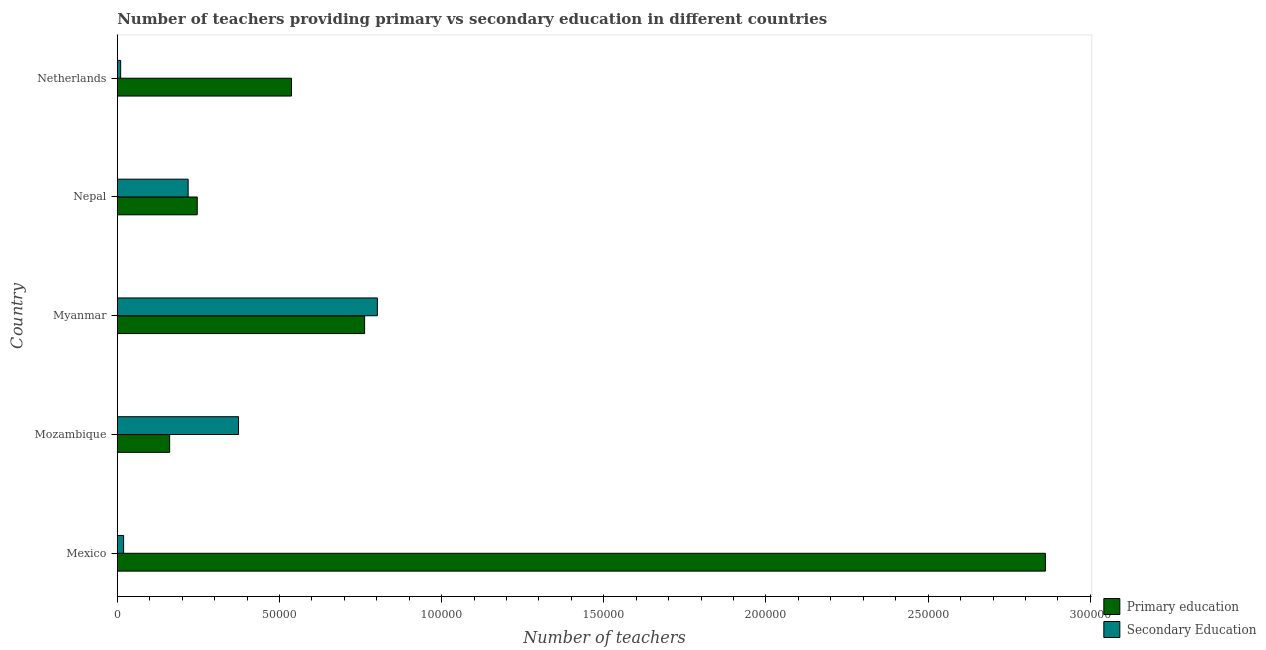How many groups of bars are there?
Provide a succinct answer. 5. Are the number of bars on each tick of the Y-axis equal?
Your answer should be compact. Yes. How many bars are there on the 2nd tick from the top?
Offer a terse response. 2. How many bars are there on the 5th tick from the bottom?
Provide a succinct answer. 2. What is the label of the 1st group of bars from the top?
Your answer should be compact. Netherlands. What is the number of secondary teachers in Mexico?
Offer a very short reply. 1954. Across all countries, what is the maximum number of primary teachers?
Your answer should be compact. 2.86e+05. Across all countries, what is the minimum number of secondary teachers?
Your response must be concise. 1039. In which country was the number of secondary teachers maximum?
Offer a terse response. Myanmar. In which country was the number of secondary teachers minimum?
Keep it short and to the point. Netherlands. What is the total number of secondary teachers in the graph?
Provide a short and direct response. 1.42e+05. What is the difference between the number of secondary teachers in Mozambique and that in Netherlands?
Offer a very short reply. 3.63e+04. What is the difference between the number of primary teachers in Myanmar and the number of secondary teachers in Nepal?
Give a very brief answer. 5.44e+04. What is the average number of secondary teachers per country?
Your response must be concise. 2.85e+04. What is the difference between the number of primary teachers and number of secondary teachers in Mexico?
Your response must be concise. 2.84e+05. What is the ratio of the number of secondary teachers in Nepal to that in Netherlands?
Provide a succinct answer. 21.03. Is the difference between the number of secondary teachers in Mozambique and Nepal greater than the difference between the number of primary teachers in Mozambique and Nepal?
Offer a terse response. Yes. What is the difference between the highest and the second highest number of primary teachers?
Provide a short and direct response. 2.10e+05. What is the difference between the highest and the lowest number of secondary teachers?
Your answer should be very brief. 7.92e+04. In how many countries, is the number of primary teachers greater than the average number of primary teachers taken over all countries?
Offer a terse response. 1. Is the sum of the number of primary teachers in Mexico and Mozambique greater than the maximum number of secondary teachers across all countries?
Keep it short and to the point. Yes. What does the 1st bar from the top in Nepal represents?
Offer a very short reply. Secondary Education. How many bars are there?
Make the answer very short. 10. Are all the bars in the graph horizontal?
Provide a short and direct response. Yes. What is the difference between two consecutive major ticks on the X-axis?
Your answer should be compact. 5.00e+04. How many legend labels are there?
Give a very brief answer. 2. What is the title of the graph?
Provide a succinct answer. Number of teachers providing primary vs secondary education in different countries. What is the label or title of the X-axis?
Make the answer very short. Number of teachers. What is the Number of teachers in Primary education in Mexico?
Make the answer very short. 2.86e+05. What is the Number of teachers in Secondary Education in Mexico?
Ensure brevity in your answer.  1954. What is the Number of teachers in Primary education in Mozambique?
Keep it short and to the point. 1.61e+04. What is the Number of teachers in Secondary Education in Mozambique?
Offer a very short reply. 3.74e+04. What is the Number of teachers of Primary education in Myanmar?
Offer a very short reply. 7.63e+04. What is the Number of teachers in Secondary Education in Myanmar?
Provide a short and direct response. 8.02e+04. What is the Number of teachers in Primary education in Nepal?
Offer a very short reply. 2.47e+04. What is the Number of teachers in Secondary Education in Nepal?
Give a very brief answer. 2.18e+04. What is the Number of teachers of Primary education in Netherlands?
Keep it short and to the point. 5.37e+04. What is the Number of teachers in Secondary Education in Netherlands?
Provide a short and direct response. 1039. Across all countries, what is the maximum Number of teachers in Primary education?
Keep it short and to the point. 2.86e+05. Across all countries, what is the maximum Number of teachers in Secondary Education?
Give a very brief answer. 8.02e+04. Across all countries, what is the minimum Number of teachers of Primary education?
Your response must be concise. 1.61e+04. Across all countries, what is the minimum Number of teachers in Secondary Education?
Provide a short and direct response. 1039. What is the total Number of teachers in Primary education in the graph?
Your answer should be compact. 4.57e+05. What is the total Number of teachers in Secondary Education in the graph?
Provide a short and direct response. 1.42e+05. What is the difference between the Number of teachers in Primary education in Mexico and that in Mozambique?
Provide a short and direct response. 2.70e+05. What is the difference between the Number of teachers of Secondary Education in Mexico and that in Mozambique?
Make the answer very short. -3.54e+04. What is the difference between the Number of teachers in Primary education in Mexico and that in Myanmar?
Ensure brevity in your answer.  2.10e+05. What is the difference between the Number of teachers of Secondary Education in Mexico and that in Myanmar?
Give a very brief answer. -7.82e+04. What is the difference between the Number of teachers of Primary education in Mexico and that in Nepal?
Give a very brief answer. 2.62e+05. What is the difference between the Number of teachers of Secondary Education in Mexico and that in Nepal?
Keep it short and to the point. -1.99e+04. What is the difference between the Number of teachers of Primary education in Mexico and that in Netherlands?
Your answer should be compact. 2.32e+05. What is the difference between the Number of teachers in Secondary Education in Mexico and that in Netherlands?
Ensure brevity in your answer.  915. What is the difference between the Number of teachers in Primary education in Mozambique and that in Myanmar?
Keep it short and to the point. -6.01e+04. What is the difference between the Number of teachers in Secondary Education in Mozambique and that in Myanmar?
Offer a very short reply. -4.28e+04. What is the difference between the Number of teachers of Primary education in Mozambique and that in Nepal?
Provide a succinct answer. -8510. What is the difference between the Number of teachers in Secondary Education in Mozambique and that in Nepal?
Provide a succinct answer. 1.55e+04. What is the difference between the Number of teachers in Primary education in Mozambique and that in Netherlands?
Your answer should be very brief. -3.76e+04. What is the difference between the Number of teachers of Secondary Education in Mozambique and that in Netherlands?
Make the answer very short. 3.63e+04. What is the difference between the Number of teachers in Primary education in Myanmar and that in Nepal?
Offer a very short reply. 5.16e+04. What is the difference between the Number of teachers of Secondary Education in Myanmar and that in Nepal?
Offer a terse response. 5.83e+04. What is the difference between the Number of teachers in Primary education in Myanmar and that in Netherlands?
Your response must be concise. 2.25e+04. What is the difference between the Number of teachers of Secondary Education in Myanmar and that in Netherlands?
Your response must be concise. 7.92e+04. What is the difference between the Number of teachers in Primary education in Nepal and that in Netherlands?
Provide a succinct answer. -2.91e+04. What is the difference between the Number of teachers of Secondary Education in Nepal and that in Netherlands?
Provide a short and direct response. 2.08e+04. What is the difference between the Number of teachers of Primary education in Mexico and the Number of teachers of Secondary Education in Mozambique?
Your answer should be very brief. 2.49e+05. What is the difference between the Number of teachers of Primary education in Mexico and the Number of teachers of Secondary Education in Myanmar?
Your answer should be compact. 2.06e+05. What is the difference between the Number of teachers in Primary education in Mexico and the Number of teachers in Secondary Education in Nepal?
Provide a short and direct response. 2.64e+05. What is the difference between the Number of teachers in Primary education in Mexico and the Number of teachers in Secondary Education in Netherlands?
Your answer should be very brief. 2.85e+05. What is the difference between the Number of teachers in Primary education in Mozambique and the Number of teachers in Secondary Education in Myanmar?
Provide a short and direct response. -6.40e+04. What is the difference between the Number of teachers of Primary education in Mozambique and the Number of teachers of Secondary Education in Nepal?
Keep it short and to the point. -5705. What is the difference between the Number of teachers of Primary education in Mozambique and the Number of teachers of Secondary Education in Netherlands?
Provide a succinct answer. 1.51e+04. What is the difference between the Number of teachers in Primary education in Myanmar and the Number of teachers in Secondary Education in Nepal?
Provide a succinct answer. 5.44e+04. What is the difference between the Number of teachers of Primary education in Myanmar and the Number of teachers of Secondary Education in Netherlands?
Your answer should be very brief. 7.52e+04. What is the difference between the Number of teachers in Primary education in Nepal and the Number of teachers in Secondary Education in Netherlands?
Your answer should be very brief. 2.36e+04. What is the average Number of teachers of Primary education per country?
Make the answer very short. 9.14e+04. What is the average Number of teachers in Secondary Education per country?
Offer a terse response. 2.85e+04. What is the difference between the Number of teachers in Primary education and Number of teachers in Secondary Education in Mexico?
Offer a very short reply. 2.84e+05. What is the difference between the Number of teachers of Primary education and Number of teachers of Secondary Education in Mozambique?
Offer a very short reply. -2.12e+04. What is the difference between the Number of teachers in Primary education and Number of teachers in Secondary Education in Myanmar?
Your response must be concise. -3939. What is the difference between the Number of teachers in Primary education and Number of teachers in Secondary Education in Nepal?
Keep it short and to the point. 2805. What is the difference between the Number of teachers in Primary education and Number of teachers in Secondary Education in Netherlands?
Keep it short and to the point. 5.27e+04. What is the ratio of the Number of teachers of Primary education in Mexico to that in Mozambique?
Provide a succinct answer. 17.73. What is the ratio of the Number of teachers in Secondary Education in Mexico to that in Mozambique?
Keep it short and to the point. 0.05. What is the ratio of the Number of teachers in Primary education in Mexico to that in Myanmar?
Offer a terse response. 3.75. What is the ratio of the Number of teachers of Secondary Education in Mexico to that in Myanmar?
Your answer should be compact. 0.02. What is the ratio of the Number of teachers in Primary education in Mexico to that in Nepal?
Your response must be concise. 11.61. What is the ratio of the Number of teachers in Secondary Education in Mexico to that in Nepal?
Offer a terse response. 0.09. What is the ratio of the Number of teachers in Primary education in Mexico to that in Netherlands?
Make the answer very short. 5.33. What is the ratio of the Number of teachers of Secondary Education in Mexico to that in Netherlands?
Your response must be concise. 1.88. What is the ratio of the Number of teachers of Primary education in Mozambique to that in Myanmar?
Offer a very short reply. 0.21. What is the ratio of the Number of teachers of Secondary Education in Mozambique to that in Myanmar?
Ensure brevity in your answer.  0.47. What is the ratio of the Number of teachers of Primary education in Mozambique to that in Nepal?
Your response must be concise. 0.65. What is the ratio of the Number of teachers of Secondary Education in Mozambique to that in Nepal?
Ensure brevity in your answer.  1.71. What is the ratio of the Number of teachers of Primary education in Mozambique to that in Netherlands?
Offer a terse response. 0.3. What is the ratio of the Number of teachers in Secondary Education in Mozambique to that in Netherlands?
Offer a terse response. 35.98. What is the ratio of the Number of teachers of Primary education in Myanmar to that in Nepal?
Your answer should be very brief. 3.09. What is the ratio of the Number of teachers of Secondary Education in Myanmar to that in Nepal?
Your answer should be compact. 3.67. What is the ratio of the Number of teachers of Primary education in Myanmar to that in Netherlands?
Ensure brevity in your answer.  1.42. What is the ratio of the Number of teachers in Secondary Education in Myanmar to that in Netherlands?
Ensure brevity in your answer.  77.18. What is the ratio of the Number of teachers of Primary education in Nepal to that in Netherlands?
Your answer should be very brief. 0.46. What is the ratio of the Number of teachers in Secondary Education in Nepal to that in Netherlands?
Offer a terse response. 21.03. What is the difference between the highest and the second highest Number of teachers of Primary education?
Keep it short and to the point. 2.10e+05. What is the difference between the highest and the second highest Number of teachers in Secondary Education?
Give a very brief answer. 4.28e+04. What is the difference between the highest and the lowest Number of teachers in Primary education?
Offer a terse response. 2.70e+05. What is the difference between the highest and the lowest Number of teachers in Secondary Education?
Your answer should be very brief. 7.92e+04. 